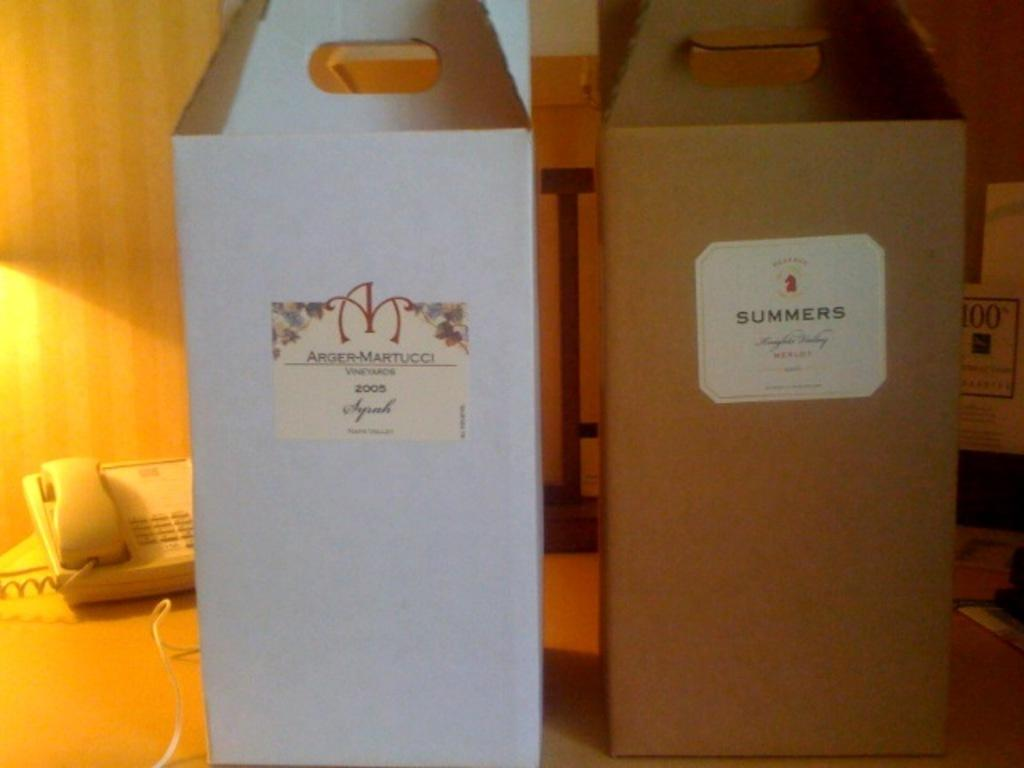<image>
Render a clear and concise summary of the photo. A box that says summer is next to a white box. 